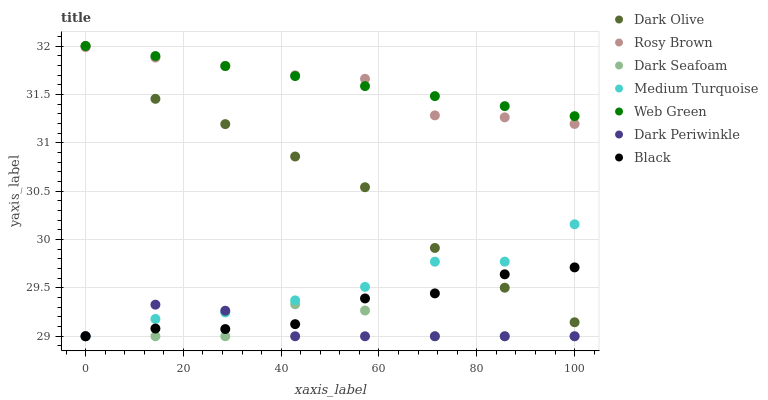Does Dark Periwinkle have the minimum area under the curve?
Answer yes or no. Yes. Does Web Green have the maximum area under the curve?
Answer yes or no. Yes. Does Rosy Brown have the minimum area under the curve?
Answer yes or no. No. Does Rosy Brown have the maximum area under the curve?
Answer yes or no. No. Is Web Green the smoothest?
Answer yes or no. Yes. Is Dark Seafoam the roughest?
Answer yes or no. Yes. Is Rosy Brown the smoothest?
Answer yes or no. No. Is Rosy Brown the roughest?
Answer yes or no. No. Does Dark Seafoam have the lowest value?
Answer yes or no. Yes. Does Rosy Brown have the lowest value?
Answer yes or no. No. Does Web Green have the highest value?
Answer yes or no. Yes. Does Rosy Brown have the highest value?
Answer yes or no. No. Is Black less than Rosy Brown?
Answer yes or no. Yes. Is Rosy Brown greater than Black?
Answer yes or no. Yes. Does Dark Seafoam intersect Dark Periwinkle?
Answer yes or no. Yes. Is Dark Seafoam less than Dark Periwinkle?
Answer yes or no. No. Is Dark Seafoam greater than Dark Periwinkle?
Answer yes or no. No. Does Black intersect Rosy Brown?
Answer yes or no. No. 